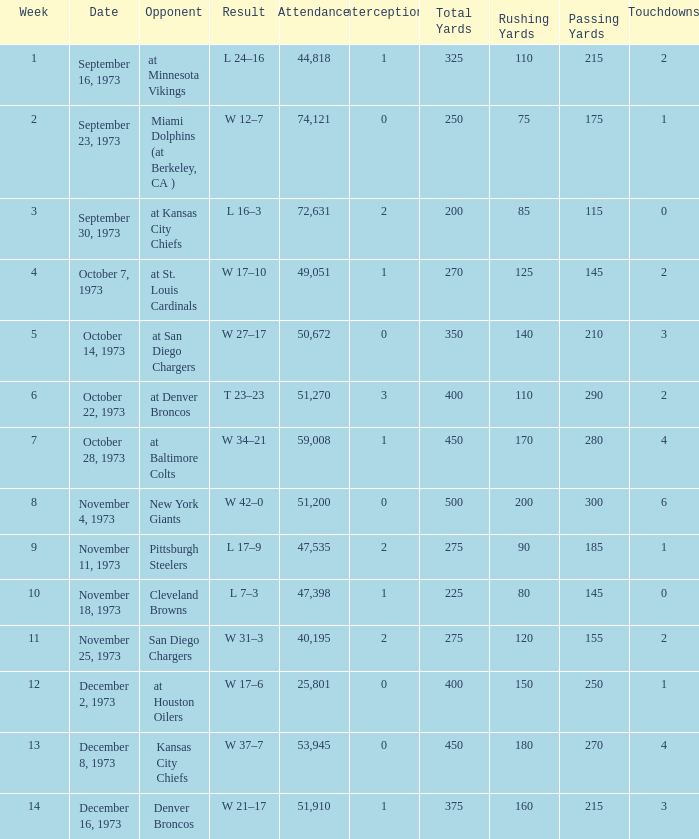What is the highest number in attendance against the game at Kansas City Chiefs? 72631.0. 